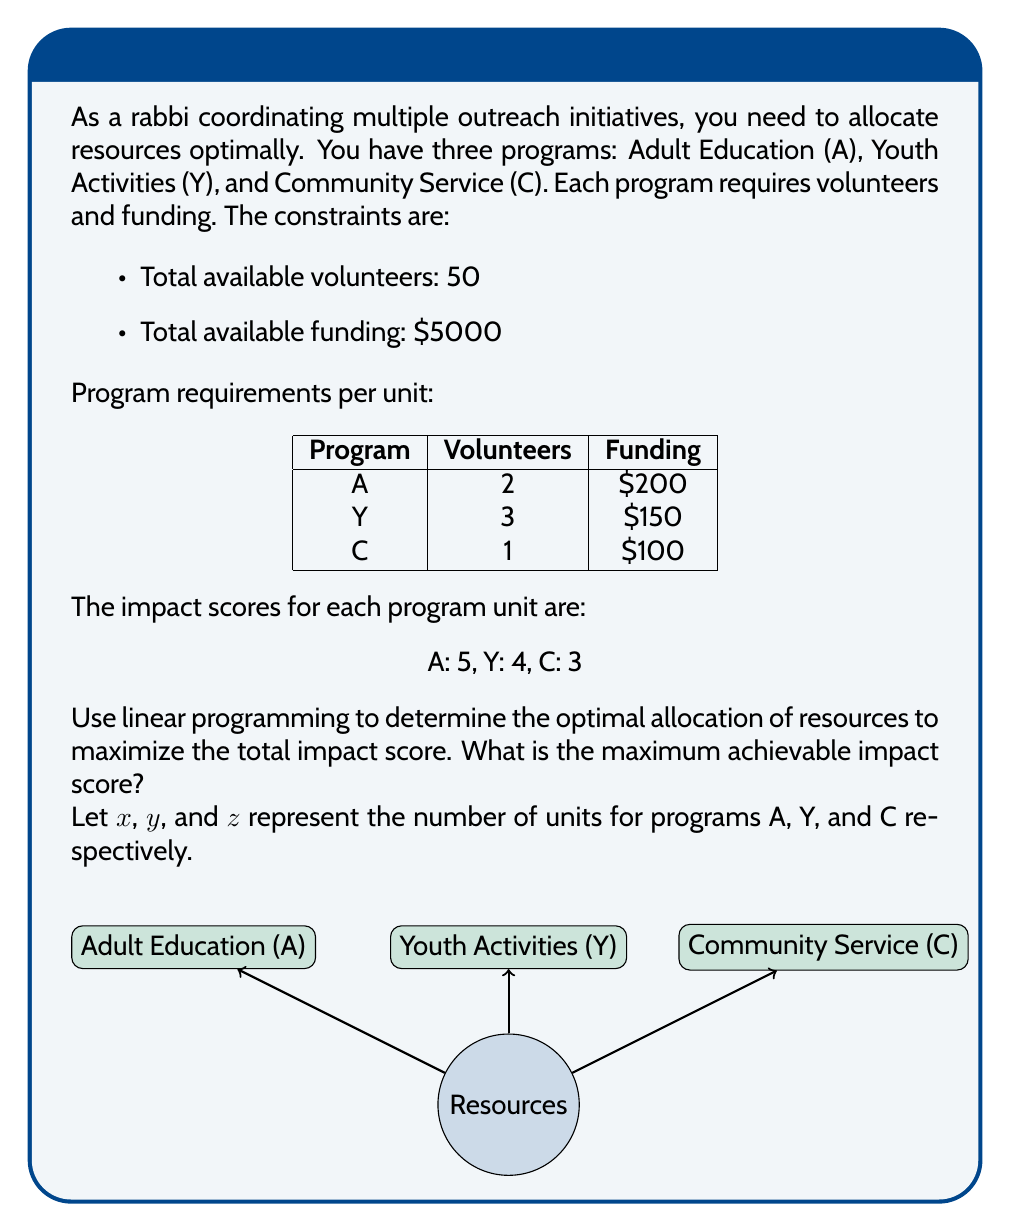Teach me how to tackle this problem. To solve this linear programming problem, we need to:

1. Define the objective function
2. List the constraints
3. Solve the system of equations

Step 1: Objective function
Maximize $Z = 5x + 4y + 3z$

Step 2: Constraints
Volunteers: $2x + 3y + z \leq 50$
Funding: $200x + 150y + 100z \leq 5000$
Non-negativity: $x, y, z \geq 0$

Step 3: Solve the system

We can use the simplex method or graphical method, but for this problem, we'll use the corner point method.

Corner points:
(0, 0, 0), (0, 0, 50), (0, 16.67, 0), (25, 0, 0), (20, 0, 10), (10, 10, 10)

Evaluating Z at each point:
(0, 0, 0): Z = 0
(0, 0, 50): Z = 150
(0, 16.67, 0): Z = 66.68
(25, 0, 0): Z = 125
(20, 0, 10): Z = 130
(10, 10, 10): Z = 120

The maximum Z value is achieved at the point (20, 0, 10).

Therefore, the optimal allocation is:
20 units of Adult Education
0 units of Youth Activities
10 units of Community Service

The maximum achievable impact score is:
$Z = 5(20) + 4(0) + 3(10) = 130$
Answer: 130 